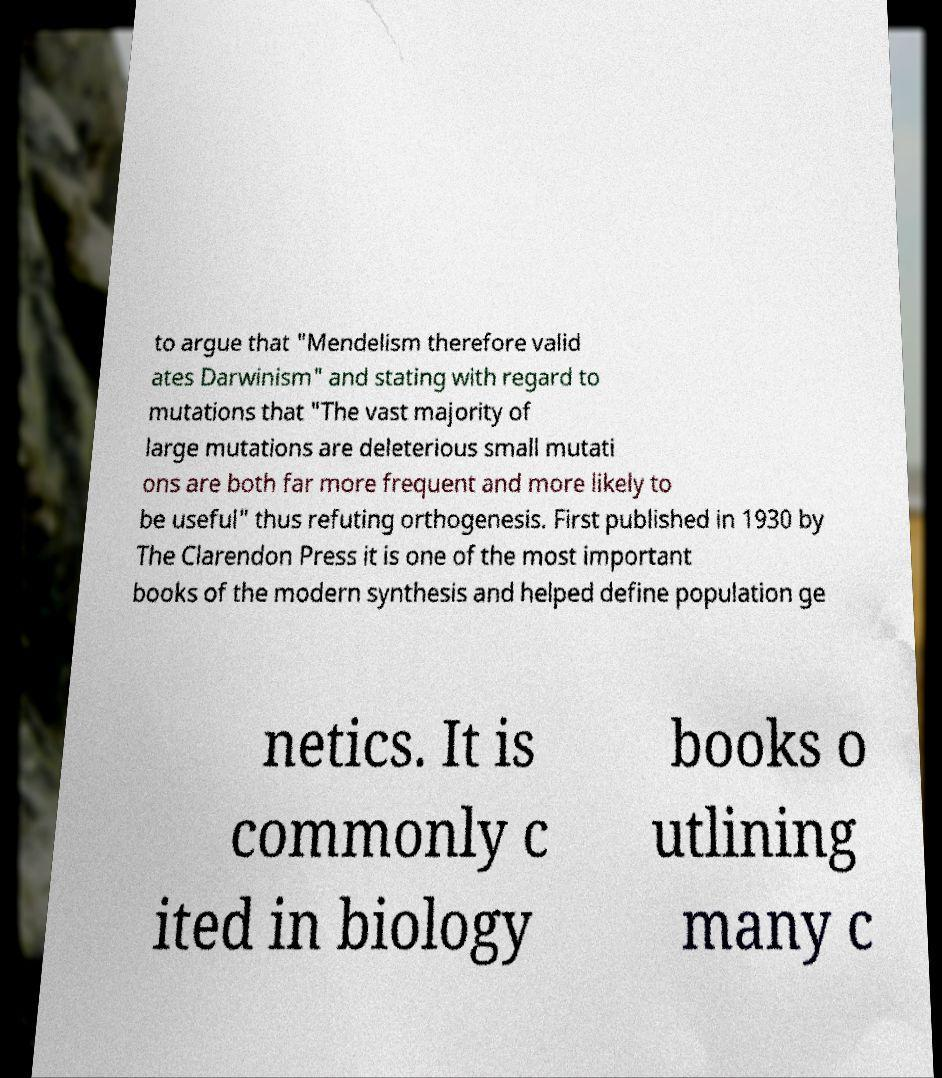Please read and relay the text visible in this image. What does it say? to argue that "Mendelism therefore valid ates Darwinism" and stating with regard to mutations that "The vast majority of large mutations are deleterious small mutati ons are both far more frequent and more likely to be useful" thus refuting orthogenesis. First published in 1930 by The Clarendon Press it is one of the most important books of the modern synthesis and helped define population ge netics. It is commonly c ited in biology books o utlining many c 